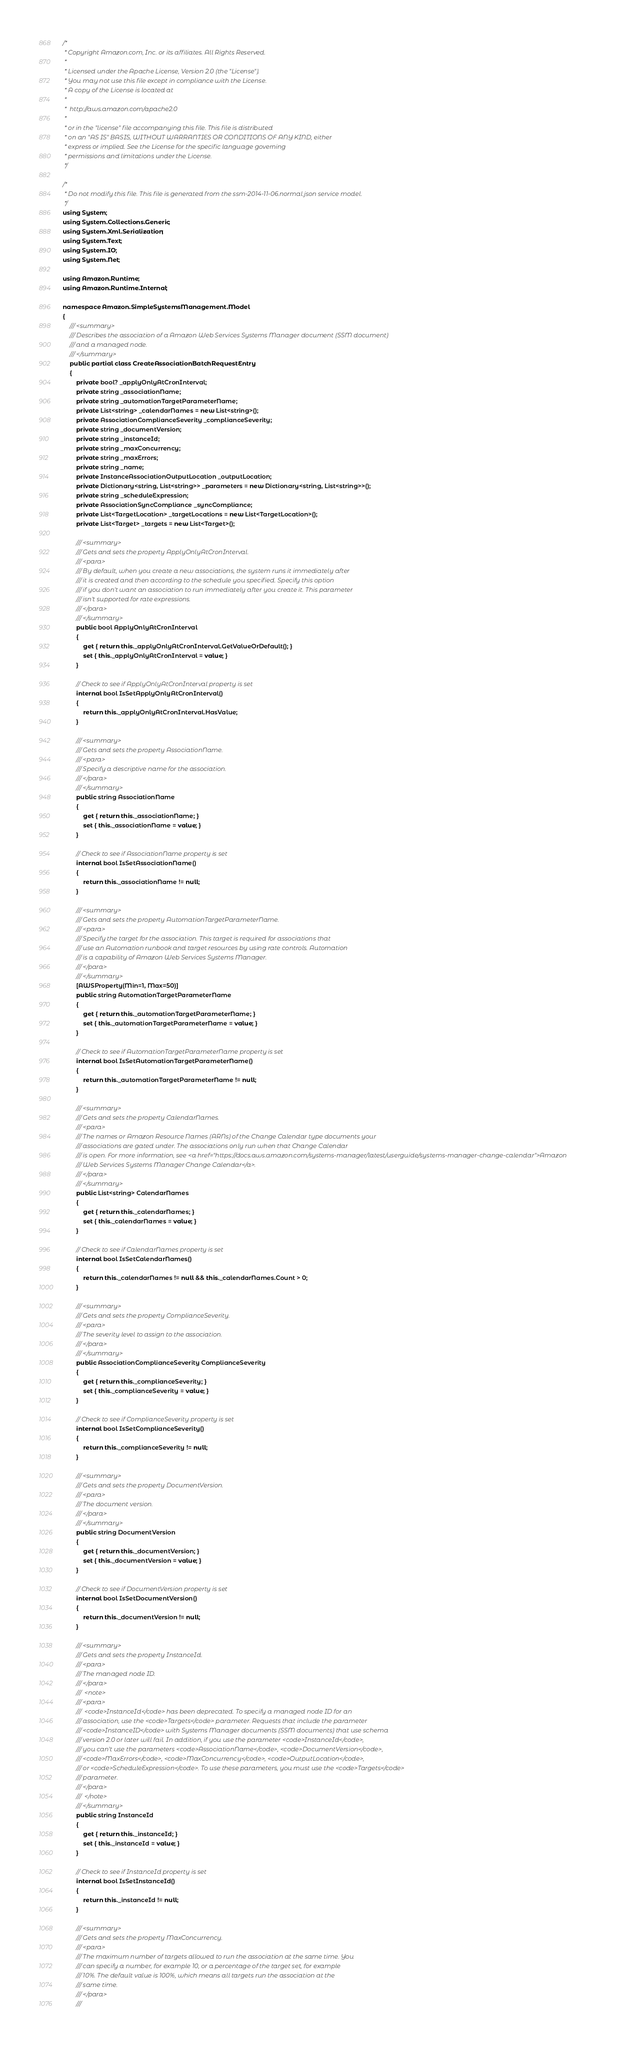<code> <loc_0><loc_0><loc_500><loc_500><_C#_>/*
 * Copyright Amazon.com, Inc. or its affiliates. All Rights Reserved.
 * 
 * Licensed under the Apache License, Version 2.0 (the "License").
 * You may not use this file except in compliance with the License.
 * A copy of the License is located at
 * 
 *  http://aws.amazon.com/apache2.0
 * 
 * or in the "license" file accompanying this file. This file is distributed
 * on an "AS IS" BASIS, WITHOUT WARRANTIES OR CONDITIONS OF ANY KIND, either
 * express or implied. See the License for the specific language governing
 * permissions and limitations under the License.
 */

/*
 * Do not modify this file. This file is generated from the ssm-2014-11-06.normal.json service model.
 */
using System;
using System.Collections.Generic;
using System.Xml.Serialization;
using System.Text;
using System.IO;
using System.Net;

using Amazon.Runtime;
using Amazon.Runtime.Internal;

namespace Amazon.SimpleSystemsManagement.Model
{
    /// <summary>
    /// Describes the association of a Amazon Web Services Systems Manager document (SSM document)
    /// and a managed node.
    /// </summary>
    public partial class CreateAssociationBatchRequestEntry
    {
        private bool? _applyOnlyAtCronInterval;
        private string _associationName;
        private string _automationTargetParameterName;
        private List<string> _calendarNames = new List<string>();
        private AssociationComplianceSeverity _complianceSeverity;
        private string _documentVersion;
        private string _instanceId;
        private string _maxConcurrency;
        private string _maxErrors;
        private string _name;
        private InstanceAssociationOutputLocation _outputLocation;
        private Dictionary<string, List<string>> _parameters = new Dictionary<string, List<string>>();
        private string _scheduleExpression;
        private AssociationSyncCompliance _syncCompliance;
        private List<TargetLocation> _targetLocations = new List<TargetLocation>();
        private List<Target> _targets = new List<Target>();

        /// <summary>
        /// Gets and sets the property ApplyOnlyAtCronInterval. 
        /// <para>
        /// By default, when you create a new associations, the system runs it immediately after
        /// it is created and then according to the schedule you specified. Specify this option
        /// if you don't want an association to run immediately after you create it. This parameter
        /// isn't supported for rate expressions.
        /// </para>
        /// </summary>
        public bool ApplyOnlyAtCronInterval
        {
            get { return this._applyOnlyAtCronInterval.GetValueOrDefault(); }
            set { this._applyOnlyAtCronInterval = value; }
        }

        // Check to see if ApplyOnlyAtCronInterval property is set
        internal bool IsSetApplyOnlyAtCronInterval()
        {
            return this._applyOnlyAtCronInterval.HasValue; 
        }

        /// <summary>
        /// Gets and sets the property AssociationName. 
        /// <para>
        /// Specify a descriptive name for the association.
        /// </para>
        /// </summary>
        public string AssociationName
        {
            get { return this._associationName; }
            set { this._associationName = value; }
        }

        // Check to see if AssociationName property is set
        internal bool IsSetAssociationName()
        {
            return this._associationName != null;
        }

        /// <summary>
        /// Gets and sets the property AutomationTargetParameterName. 
        /// <para>
        /// Specify the target for the association. This target is required for associations that
        /// use an Automation runbook and target resources by using rate controls. Automation
        /// is a capability of Amazon Web Services Systems Manager.
        /// </para>
        /// </summary>
        [AWSProperty(Min=1, Max=50)]
        public string AutomationTargetParameterName
        {
            get { return this._automationTargetParameterName; }
            set { this._automationTargetParameterName = value; }
        }

        // Check to see if AutomationTargetParameterName property is set
        internal bool IsSetAutomationTargetParameterName()
        {
            return this._automationTargetParameterName != null;
        }

        /// <summary>
        /// Gets and sets the property CalendarNames. 
        /// <para>
        /// The names or Amazon Resource Names (ARNs) of the Change Calendar type documents your
        /// associations are gated under. The associations only run when that Change Calendar
        /// is open. For more information, see <a href="https://docs.aws.amazon.com/systems-manager/latest/userguide/systems-manager-change-calendar">Amazon
        /// Web Services Systems Manager Change Calendar</a>.
        /// </para>
        /// </summary>
        public List<string> CalendarNames
        {
            get { return this._calendarNames; }
            set { this._calendarNames = value; }
        }

        // Check to see if CalendarNames property is set
        internal bool IsSetCalendarNames()
        {
            return this._calendarNames != null && this._calendarNames.Count > 0; 
        }

        /// <summary>
        /// Gets and sets the property ComplianceSeverity. 
        /// <para>
        /// The severity level to assign to the association.
        /// </para>
        /// </summary>
        public AssociationComplianceSeverity ComplianceSeverity
        {
            get { return this._complianceSeverity; }
            set { this._complianceSeverity = value; }
        }

        // Check to see if ComplianceSeverity property is set
        internal bool IsSetComplianceSeverity()
        {
            return this._complianceSeverity != null;
        }

        /// <summary>
        /// Gets and sets the property DocumentVersion. 
        /// <para>
        /// The document version.
        /// </para>
        /// </summary>
        public string DocumentVersion
        {
            get { return this._documentVersion; }
            set { this._documentVersion = value; }
        }

        // Check to see if DocumentVersion property is set
        internal bool IsSetDocumentVersion()
        {
            return this._documentVersion != null;
        }

        /// <summary>
        /// Gets and sets the property InstanceId. 
        /// <para>
        /// The managed node ID.
        /// </para>
        ///  <note> 
        /// <para>
        ///  <code>InstanceId</code> has been deprecated. To specify a managed node ID for an
        /// association, use the <code>Targets</code> parameter. Requests that include the parameter
        /// <code>InstanceID</code> with Systems Manager documents (SSM documents) that use schema
        /// version 2.0 or later will fail. In addition, if you use the parameter <code>InstanceId</code>,
        /// you can't use the parameters <code>AssociationName</code>, <code>DocumentVersion</code>,
        /// <code>MaxErrors</code>, <code>MaxConcurrency</code>, <code>OutputLocation</code>,
        /// or <code>ScheduleExpression</code>. To use these parameters, you must use the <code>Targets</code>
        /// parameter.
        /// </para>
        ///  </note>
        /// </summary>
        public string InstanceId
        {
            get { return this._instanceId; }
            set { this._instanceId = value; }
        }

        // Check to see if InstanceId property is set
        internal bool IsSetInstanceId()
        {
            return this._instanceId != null;
        }

        /// <summary>
        /// Gets and sets the property MaxConcurrency. 
        /// <para>
        /// The maximum number of targets allowed to run the association at the same time. You
        /// can specify a number, for example 10, or a percentage of the target set, for example
        /// 10%. The default value is 100%, which means all targets run the association at the
        /// same time.
        /// </para>
        ///  </code> 